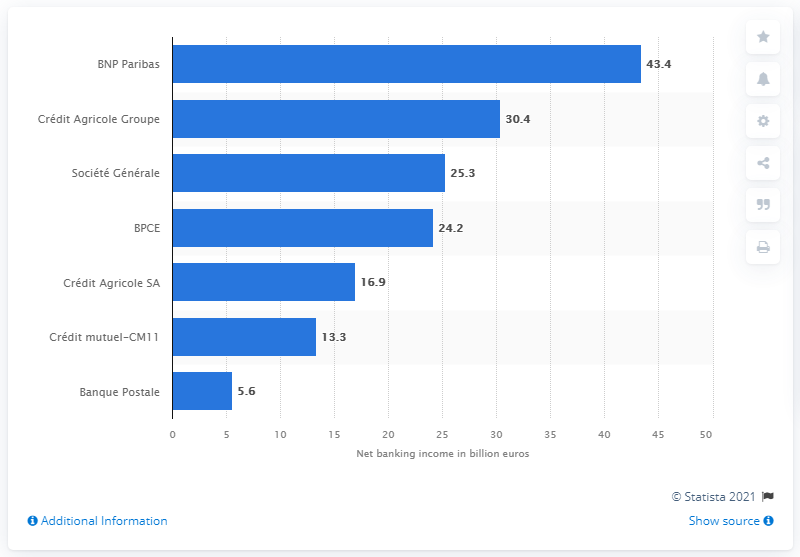What was the performance trend for smaller banks like Banque Postale? In 2016, Banque Postale had a net banking income of 5.6 billion euros, aligning it with the lower end of the performance spectrum among the major French banks shown in the chart. 